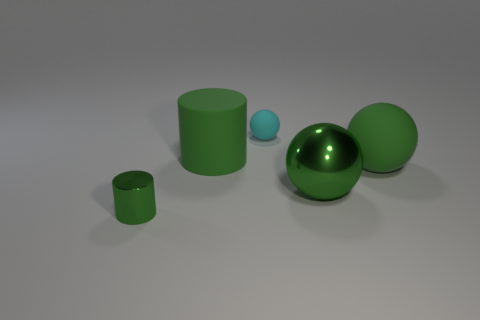Does the small object to the left of the tiny sphere have the same material as the tiny thing that is behind the tiny metallic object?
Offer a very short reply. No. What number of matte objects are green objects or large cylinders?
Your answer should be compact. 2. What is the green thing that is in front of the shiny object that is right of the metallic thing that is on the left side of the large green metal object made of?
Offer a terse response. Metal. There is a thing that is behind the big green cylinder; is it the same shape as the rubber thing on the right side of the big metallic sphere?
Ensure brevity in your answer.  Yes. What color is the ball on the left side of the green shiny object that is behind the metallic cylinder?
Provide a succinct answer. Cyan. What number of cubes are either tiny metal things or large matte things?
Ensure brevity in your answer.  0. There is a object to the right of the metallic object that is on the right side of the small green cylinder; what number of big green cylinders are in front of it?
Your answer should be compact. 0. What is the size of the shiny ball that is the same color as the metal cylinder?
Your response must be concise. Large. Are there any tiny green things that have the same material as the small cyan thing?
Your answer should be compact. No. Is the small green cylinder made of the same material as the cyan sphere?
Your response must be concise. No. 